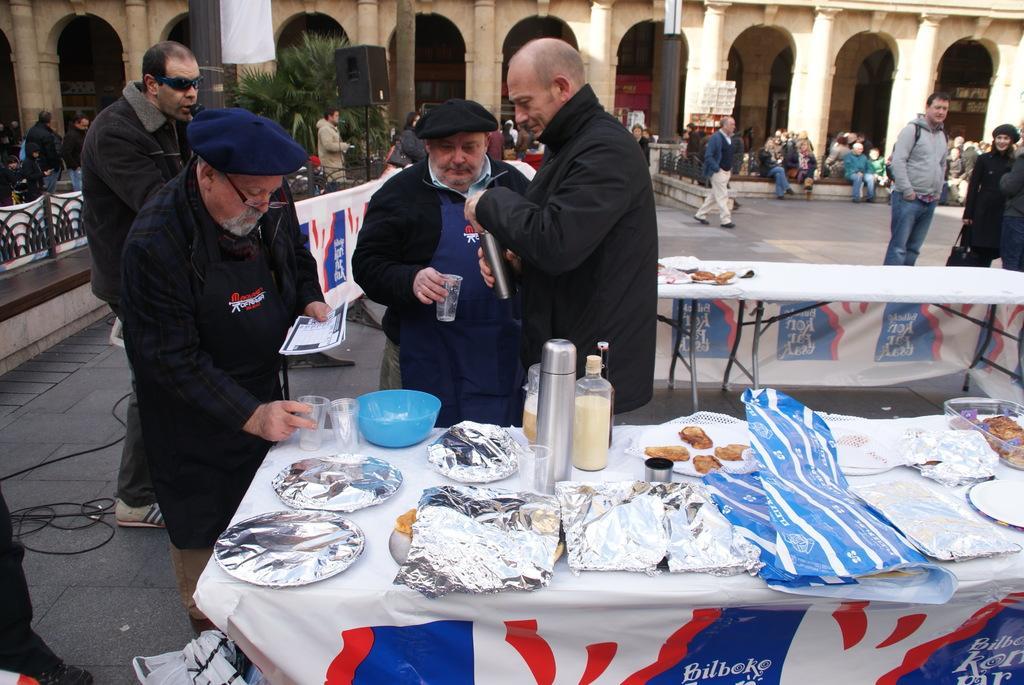Describe this image in one or two sentences. In this image I can see number of people are standing in the front and in the background I can see few people are sitting. I can also see few tables on the right side and on it I can see few plates, food, few bottles, few glasses and aluminium foils. I can also see few other stuffs on these tables. In the background I can see a tree, a building, few boards and in the front I can see one person is holding a white colour thing and I can also see one of them is holding a glass and near him I can see one is holding a bottle. 